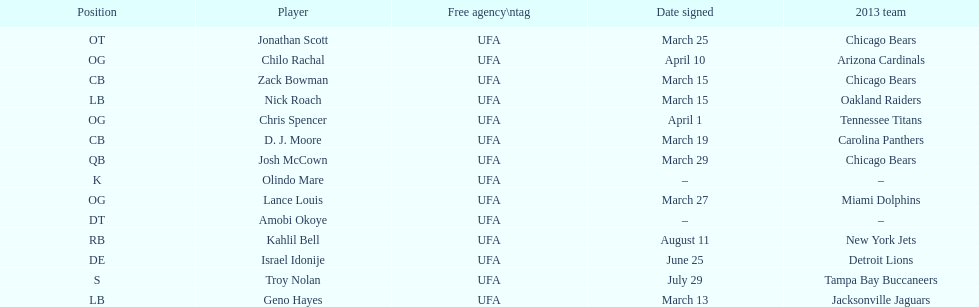How many players were signed in march? 7. 